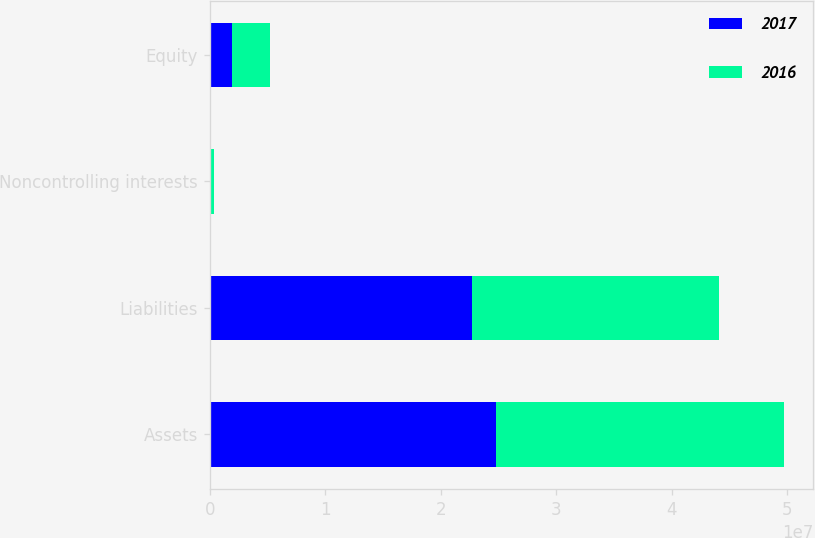Convert chart to OTSL. <chart><loc_0><loc_0><loc_500><loc_500><stacked_bar_chart><ecel><fcel>Assets<fcel>Liabilities<fcel>Noncontrolling interests<fcel>Equity<nl><fcel>2017<fcel>2.4812e+07<fcel>2.2739e+07<fcel>140000<fcel>1.933e+06<nl><fcel>2016<fcel>2.4926e+07<fcel>2.1357e+07<fcel>265000<fcel>3.304e+06<nl></chart> 